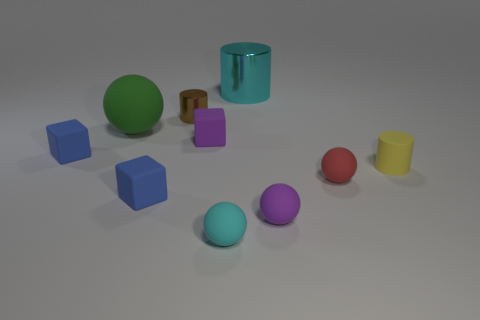There is a tiny object that is on the right side of the small rubber sphere behind the purple sphere; is there a small cylinder that is to the right of it?
Your response must be concise. No. There is a sphere that is the same color as the big shiny thing; what is its size?
Your response must be concise. Small. Are there any tiny purple cubes in front of the small yellow matte cylinder?
Offer a terse response. No. What number of other objects are the same shape as the green rubber object?
Keep it short and to the point. 3. The matte cylinder that is the same size as the brown shiny cylinder is what color?
Your answer should be compact. Yellow. Is the number of big cyan cylinders that are on the right side of the large cyan shiny thing less than the number of purple rubber cubes that are on the left side of the tiny brown metallic cylinder?
Keep it short and to the point. No. What number of tiny matte balls are on the right side of the cyan thing that is in front of the tiny thing that is behind the big rubber object?
Your response must be concise. 2. There is a purple object that is the same shape as the red matte thing; what size is it?
Your answer should be very brief. Small. Is there any other thing that is the same size as the red rubber thing?
Your response must be concise. Yes. Are there fewer cyan objects that are behind the big sphere than tiny gray matte cubes?
Your response must be concise. No. 